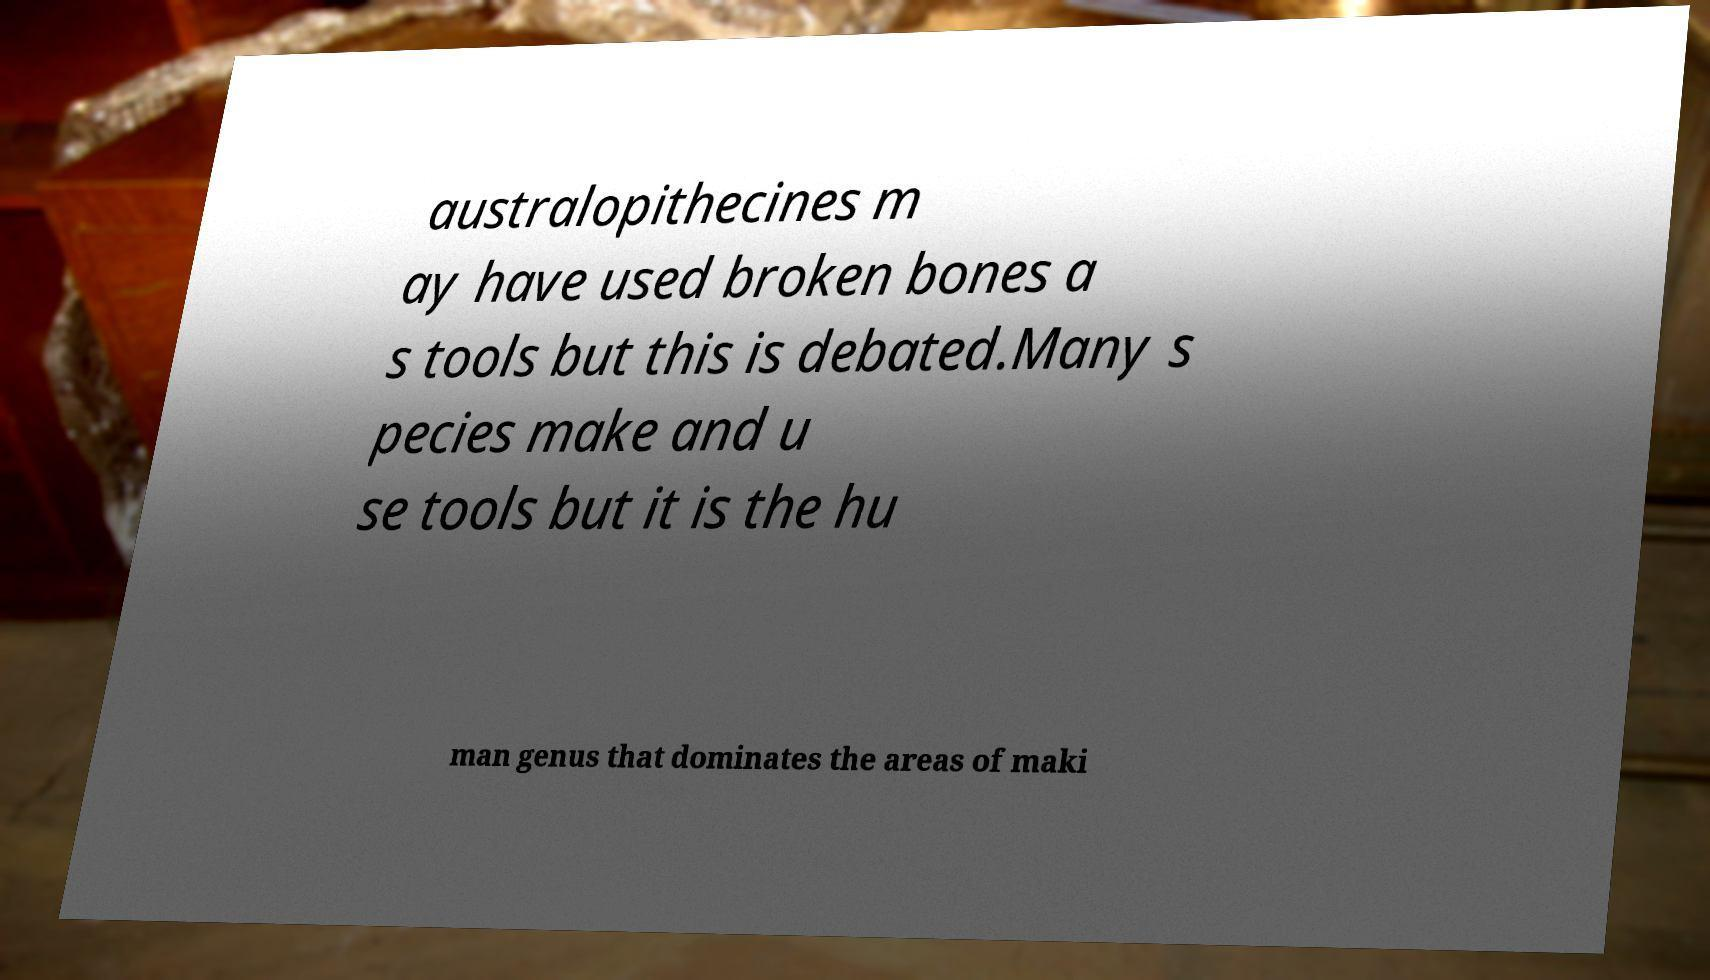Please identify and transcribe the text found in this image. australopithecines m ay have used broken bones a s tools but this is debated.Many s pecies make and u se tools but it is the hu man genus that dominates the areas of maki 